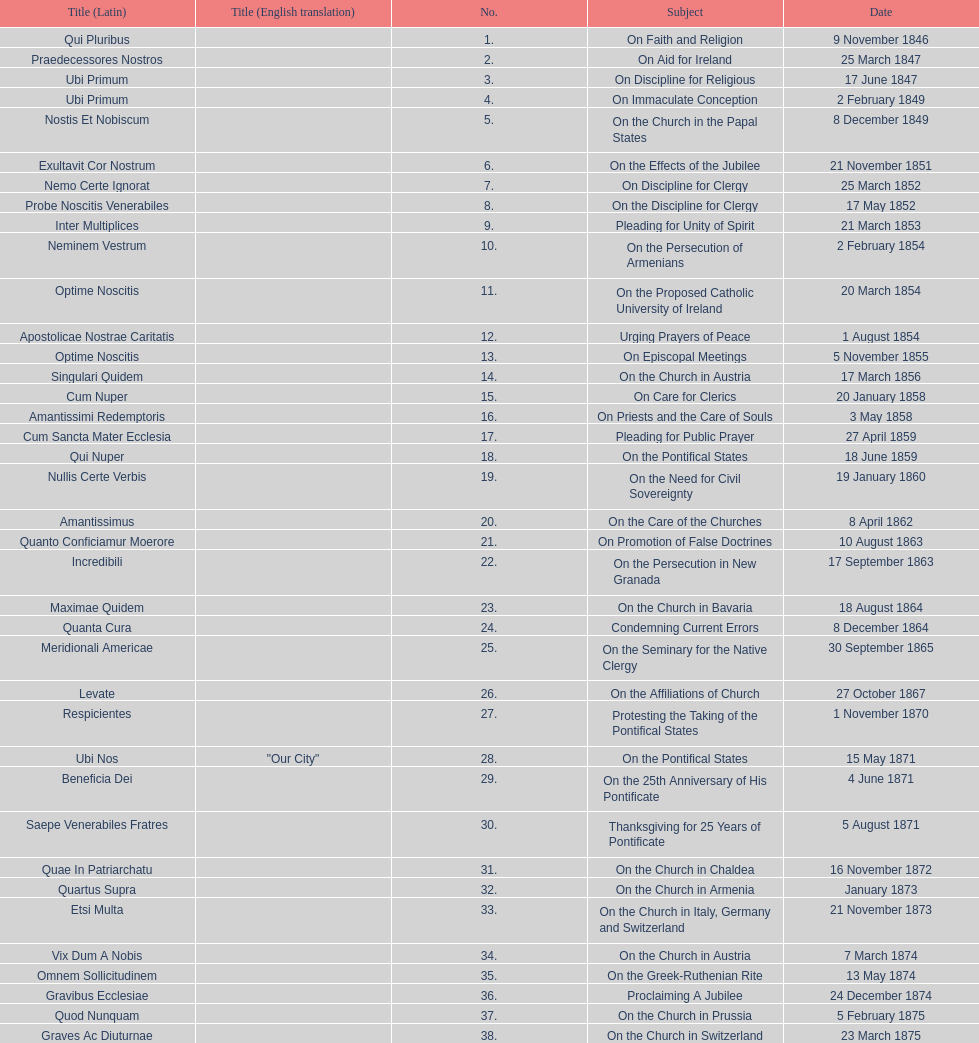How many encyclicals were issued between august 15, 1854 and october 26, 1867? 13. 